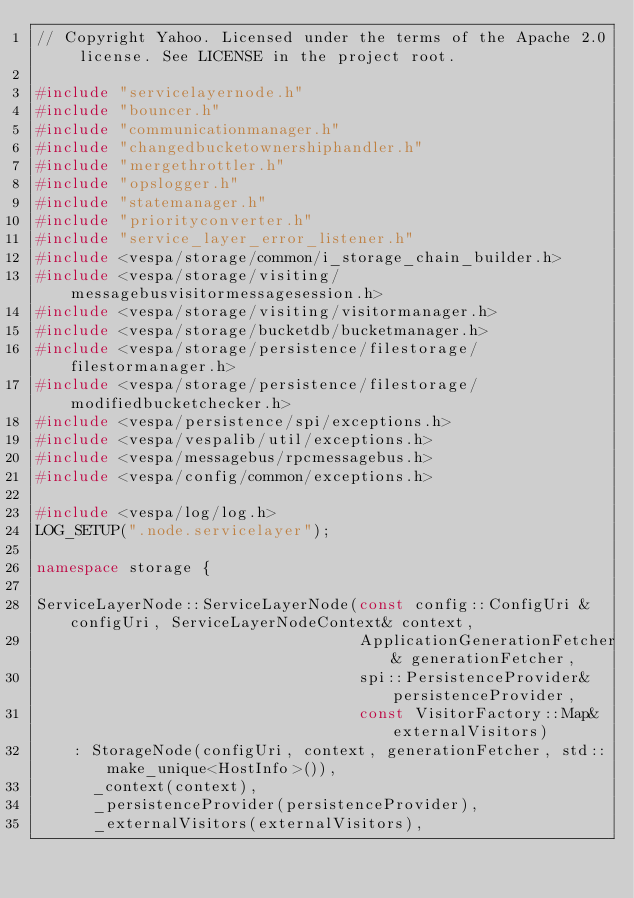<code> <loc_0><loc_0><loc_500><loc_500><_C++_>// Copyright Yahoo. Licensed under the terms of the Apache 2.0 license. See LICENSE in the project root.

#include "servicelayernode.h"
#include "bouncer.h"
#include "communicationmanager.h"
#include "changedbucketownershiphandler.h"
#include "mergethrottler.h"
#include "opslogger.h"
#include "statemanager.h"
#include "priorityconverter.h"
#include "service_layer_error_listener.h"
#include <vespa/storage/common/i_storage_chain_builder.h>
#include <vespa/storage/visiting/messagebusvisitormessagesession.h>
#include <vespa/storage/visiting/visitormanager.h>
#include <vespa/storage/bucketdb/bucketmanager.h>
#include <vespa/storage/persistence/filestorage/filestormanager.h>
#include <vespa/storage/persistence/filestorage/modifiedbucketchecker.h>
#include <vespa/persistence/spi/exceptions.h>
#include <vespa/vespalib/util/exceptions.h>
#include <vespa/messagebus/rpcmessagebus.h>
#include <vespa/config/common/exceptions.h>

#include <vespa/log/log.h>
LOG_SETUP(".node.servicelayer");

namespace storage {

ServiceLayerNode::ServiceLayerNode(const config::ConfigUri & configUri, ServiceLayerNodeContext& context,
                                   ApplicationGenerationFetcher& generationFetcher,
                                   spi::PersistenceProvider& persistenceProvider,
                                   const VisitorFactory::Map& externalVisitors)
    : StorageNode(configUri, context, generationFetcher, std::make_unique<HostInfo>()),
      _context(context),
      _persistenceProvider(persistenceProvider),
      _externalVisitors(externalVisitors),</code> 